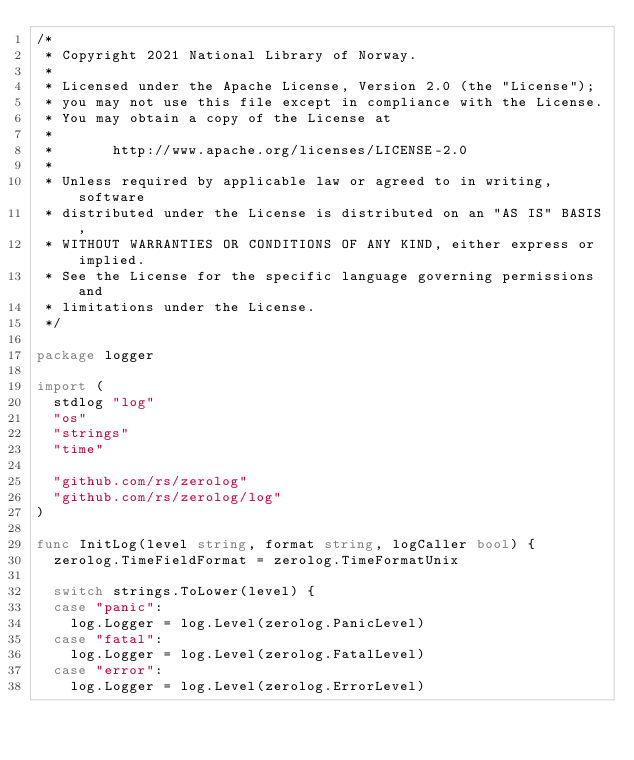Convert code to text. <code><loc_0><loc_0><loc_500><loc_500><_Go_>/*
 * Copyright 2021 National Library of Norway.
 *
 * Licensed under the Apache License, Version 2.0 (the "License");
 * you may not use this file except in compliance with the License.
 * You may obtain a copy of the License at
 *
 *       http://www.apache.org/licenses/LICENSE-2.0
 *
 * Unless required by applicable law or agreed to in writing, software
 * distributed under the License is distributed on an "AS IS" BASIS,
 * WITHOUT WARRANTIES OR CONDITIONS OF ANY KIND, either express or implied.
 * See the License for the specific language governing permissions and
 * limitations under the License.
 */

package logger

import (
	stdlog "log"
	"os"
	"strings"
	"time"

	"github.com/rs/zerolog"
	"github.com/rs/zerolog/log"
)

func InitLog(level string, format string, logCaller bool) {
	zerolog.TimeFieldFormat = zerolog.TimeFormatUnix

	switch strings.ToLower(level) {
	case "panic":
		log.Logger = log.Level(zerolog.PanicLevel)
	case "fatal":
		log.Logger = log.Level(zerolog.FatalLevel)
	case "error":
		log.Logger = log.Level(zerolog.ErrorLevel)</code> 